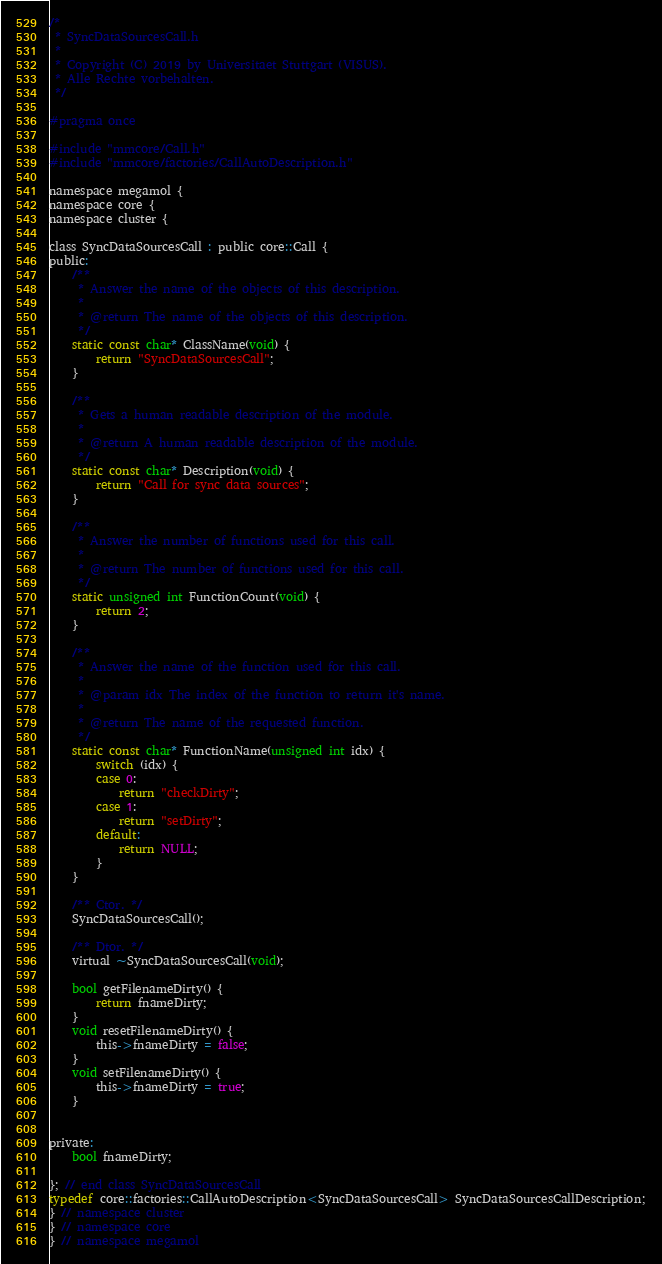Convert code to text. <code><loc_0><loc_0><loc_500><loc_500><_C_>/*
 * SyncDataSourcesCall.h
 *
 * Copyright (C) 2019 by Universitaet Stuttgart (VISUS).
 * Alle Rechte vorbehalten.
 */

#pragma once

#include "mmcore/Call.h"
#include "mmcore/factories/CallAutoDescription.h"

namespace megamol {
namespace core {
namespace cluster {

class SyncDataSourcesCall : public core::Call {
public:
    /**
     * Answer the name of the objects of this description.
     *
     * @return The name of the objects of this description.
     */
    static const char* ClassName(void) {
        return "SyncDataSourcesCall";
    }

    /**
     * Gets a human readable description of the module.
     *
     * @return A human readable description of the module.
     */
    static const char* Description(void) {
        return "Call for sync data sources";
    }

    /**
     * Answer the number of functions used for this call.
     *
     * @return The number of functions used for this call.
     */
    static unsigned int FunctionCount(void) {
        return 2;
    }

    /**
     * Answer the name of the function used for this call.
     *
     * @param idx The index of the function to return it's name.
     *
     * @return The name of the requested function.
     */
    static const char* FunctionName(unsigned int idx) {
        switch (idx) {
        case 0:
            return "checkDirty";
        case 1:
            return "setDirty";
        default:
            return NULL;
        }
    }

    /** Ctor. */
    SyncDataSourcesCall();

    /** Dtor. */
    virtual ~SyncDataSourcesCall(void);

    bool getFilenameDirty() {
        return fnameDirty;
    }
    void resetFilenameDirty() {
        this->fnameDirty = false;
    }
    void setFilenameDirty() {
        this->fnameDirty = true;
    }


private:
    bool fnameDirty;

}; // end class SyncDataSourcesCall
typedef core::factories::CallAutoDescription<SyncDataSourcesCall> SyncDataSourcesCallDescription;
} // namespace cluster
} // namespace core
} // namespace megamol
</code> 